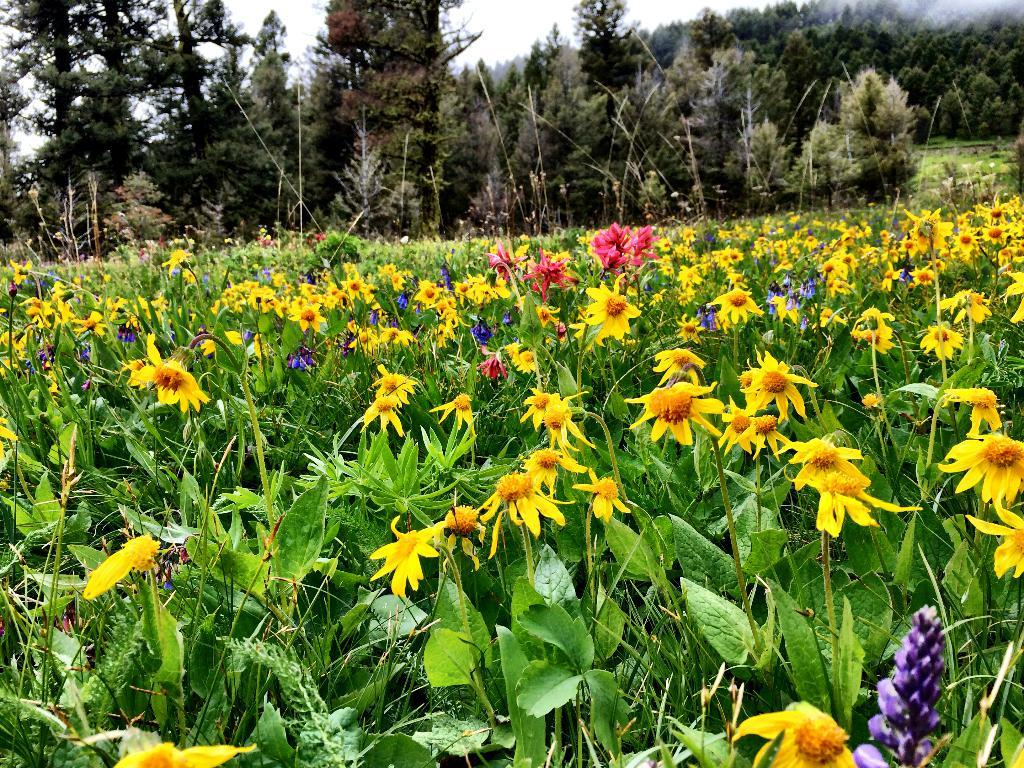What type of plants are present in the image? There are plants with colorful flowers in the image. What colors can be seen in the flowers? The flowers are in yellow, pink, and purple colors. What can be seen in the background of the image? There are trees visible in the background of the image. How would you describe the sky in the image? The sky is white in the image. What type of advertisement can be seen on the coil in the image? There is no coil or advertisement present in the image. What type of produce is being sold in the image? There is no produce being sold in the image; it features colorful flowers on plants. 